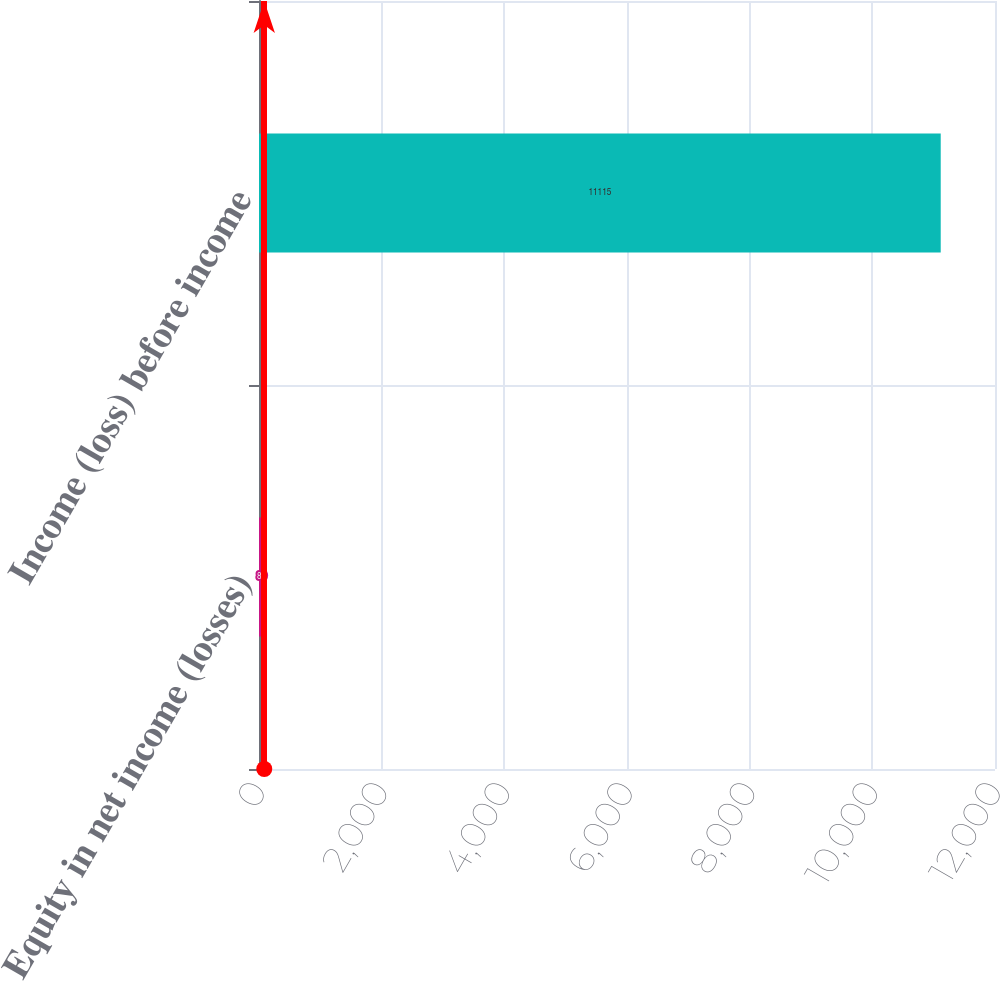Convert chart to OTSL. <chart><loc_0><loc_0><loc_500><loc_500><bar_chart><fcel>Equity in net income (losses)<fcel>Income (loss) before income<nl><fcel>86<fcel>11115<nl></chart> 